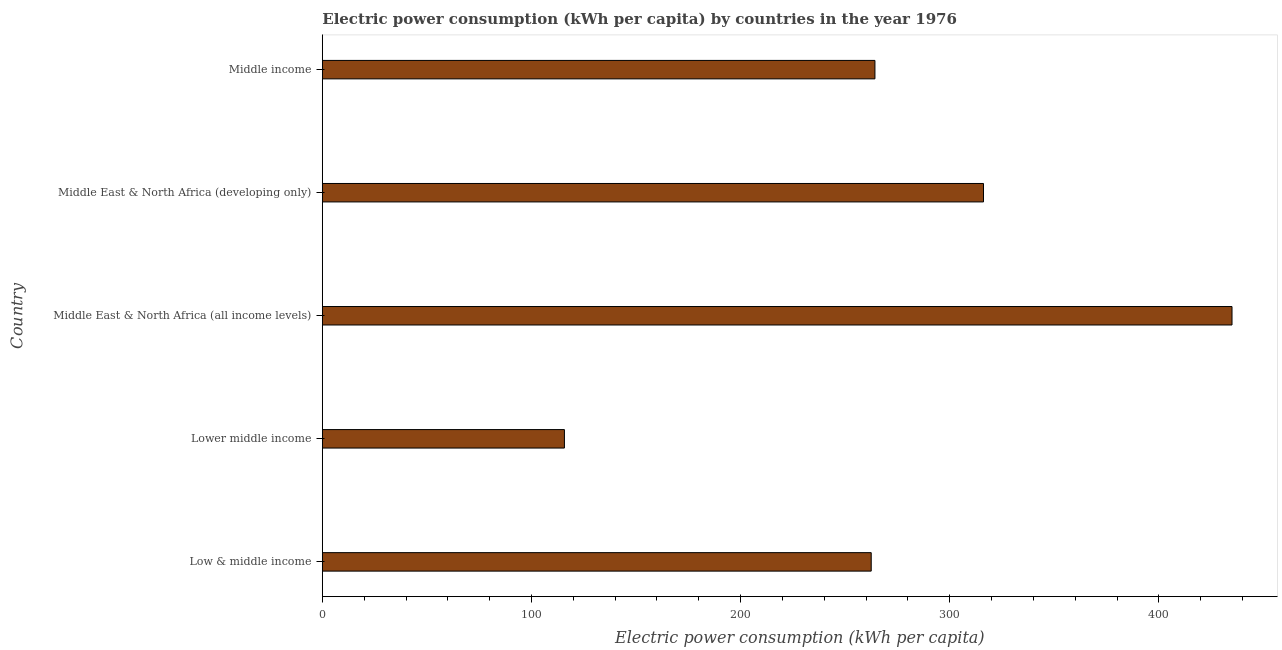Does the graph contain any zero values?
Give a very brief answer. No. What is the title of the graph?
Offer a very short reply. Electric power consumption (kWh per capita) by countries in the year 1976. What is the label or title of the X-axis?
Make the answer very short. Electric power consumption (kWh per capita). What is the label or title of the Y-axis?
Ensure brevity in your answer.  Country. What is the electric power consumption in Middle East & North Africa (all income levels)?
Make the answer very short. 434.92. Across all countries, what is the maximum electric power consumption?
Your answer should be compact. 434.92. Across all countries, what is the minimum electric power consumption?
Provide a succinct answer. 115.74. In which country was the electric power consumption maximum?
Your response must be concise. Middle East & North Africa (all income levels). In which country was the electric power consumption minimum?
Offer a terse response. Lower middle income. What is the sum of the electric power consumption?
Ensure brevity in your answer.  1393.39. What is the difference between the electric power consumption in Lower middle income and Middle East & North Africa (all income levels)?
Provide a succinct answer. -319.17. What is the average electric power consumption per country?
Your answer should be compact. 278.68. What is the median electric power consumption?
Make the answer very short. 264.2. In how many countries, is the electric power consumption greater than 80 kWh per capita?
Give a very brief answer. 5. What is the ratio of the electric power consumption in Lower middle income to that in Middle East & North Africa (all income levels)?
Your answer should be very brief. 0.27. Is the electric power consumption in Low & middle income less than that in Middle East & North Africa (all income levels)?
Your answer should be very brief. Yes. Is the difference between the electric power consumption in Low & middle income and Lower middle income greater than the difference between any two countries?
Your answer should be compact. No. What is the difference between the highest and the second highest electric power consumption?
Provide a short and direct response. 118.81. Is the sum of the electric power consumption in Lower middle income and Middle East & North Africa (developing only) greater than the maximum electric power consumption across all countries?
Provide a succinct answer. No. What is the difference between the highest and the lowest electric power consumption?
Ensure brevity in your answer.  319.17. In how many countries, is the electric power consumption greater than the average electric power consumption taken over all countries?
Offer a very short reply. 2. What is the difference between two consecutive major ticks on the X-axis?
Keep it short and to the point. 100. Are the values on the major ticks of X-axis written in scientific E-notation?
Offer a terse response. No. What is the Electric power consumption (kWh per capita) of Low & middle income?
Offer a very short reply. 262.42. What is the Electric power consumption (kWh per capita) of Lower middle income?
Offer a very short reply. 115.74. What is the Electric power consumption (kWh per capita) in Middle East & North Africa (all income levels)?
Give a very brief answer. 434.92. What is the Electric power consumption (kWh per capita) in Middle East & North Africa (developing only)?
Offer a very short reply. 316.11. What is the Electric power consumption (kWh per capita) in Middle income?
Ensure brevity in your answer.  264.2. What is the difference between the Electric power consumption (kWh per capita) in Low & middle income and Lower middle income?
Your answer should be very brief. 146.68. What is the difference between the Electric power consumption (kWh per capita) in Low & middle income and Middle East & North Africa (all income levels)?
Provide a short and direct response. -172.49. What is the difference between the Electric power consumption (kWh per capita) in Low & middle income and Middle East & North Africa (developing only)?
Your answer should be very brief. -53.69. What is the difference between the Electric power consumption (kWh per capita) in Low & middle income and Middle income?
Offer a very short reply. -1.78. What is the difference between the Electric power consumption (kWh per capita) in Lower middle income and Middle East & North Africa (all income levels)?
Give a very brief answer. -319.17. What is the difference between the Electric power consumption (kWh per capita) in Lower middle income and Middle East & North Africa (developing only)?
Offer a terse response. -200.37. What is the difference between the Electric power consumption (kWh per capita) in Lower middle income and Middle income?
Offer a terse response. -148.46. What is the difference between the Electric power consumption (kWh per capita) in Middle East & North Africa (all income levels) and Middle East & North Africa (developing only)?
Your answer should be very brief. 118.81. What is the difference between the Electric power consumption (kWh per capita) in Middle East & North Africa (all income levels) and Middle income?
Give a very brief answer. 170.71. What is the difference between the Electric power consumption (kWh per capita) in Middle East & North Africa (developing only) and Middle income?
Provide a short and direct response. 51.91. What is the ratio of the Electric power consumption (kWh per capita) in Low & middle income to that in Lower middle income?
Keep it short and to the point. 2.27. What is the ratio of the Electric power consumption (kWh per capita) in Low & middle income to that in Middle East & North Africa (all income levels)?
Your response must be concise. 0.6. What is the ratio of the Electric power consumption (kWh per capita) in Low & middle income to that in Middle East & North Africa (developing only)?
Keep it short and to the point. 0.83. What is the ratio of the Electric power consumption (kWh per capita) in Low & middle income to that in Middle income?
Provide a succinct answer. 0.99. What is the ratio of the Electric power consumption (kWh per capita) in Lower middle income to that in Middle East & North Africa (all income levels)?
Your answer should be very brief. 0.27. What is the ratio of the Electric power consumption (kWh per capita) in Lower middle income to that in Middle East & North Africa (developing only)?
Your response must be concise. 0.37. What is the ratio of the Electric power consumption (kWh per capita) in Lower middle income to that in Middle income?
Give a very brief answer. 0.44. What is the ratio of the Electric power consumption (kWh per capita) in Middle East & North Africa (all income levels) to that in Middle East & North Africa (developing only)?
Your answer should be very brief. 1.38. What is the ratio of the Electric power consumption (kWh per capita) in Middle East & North Africa (all income levels) to that in Middle income?
Provide a succinct answer. 1.65. What is the ratio of the Electric power consumption (kWh per capita) in Middle East & North Africa (developing only) to that in Middle income?
Offer a very short reply. 1.2. 